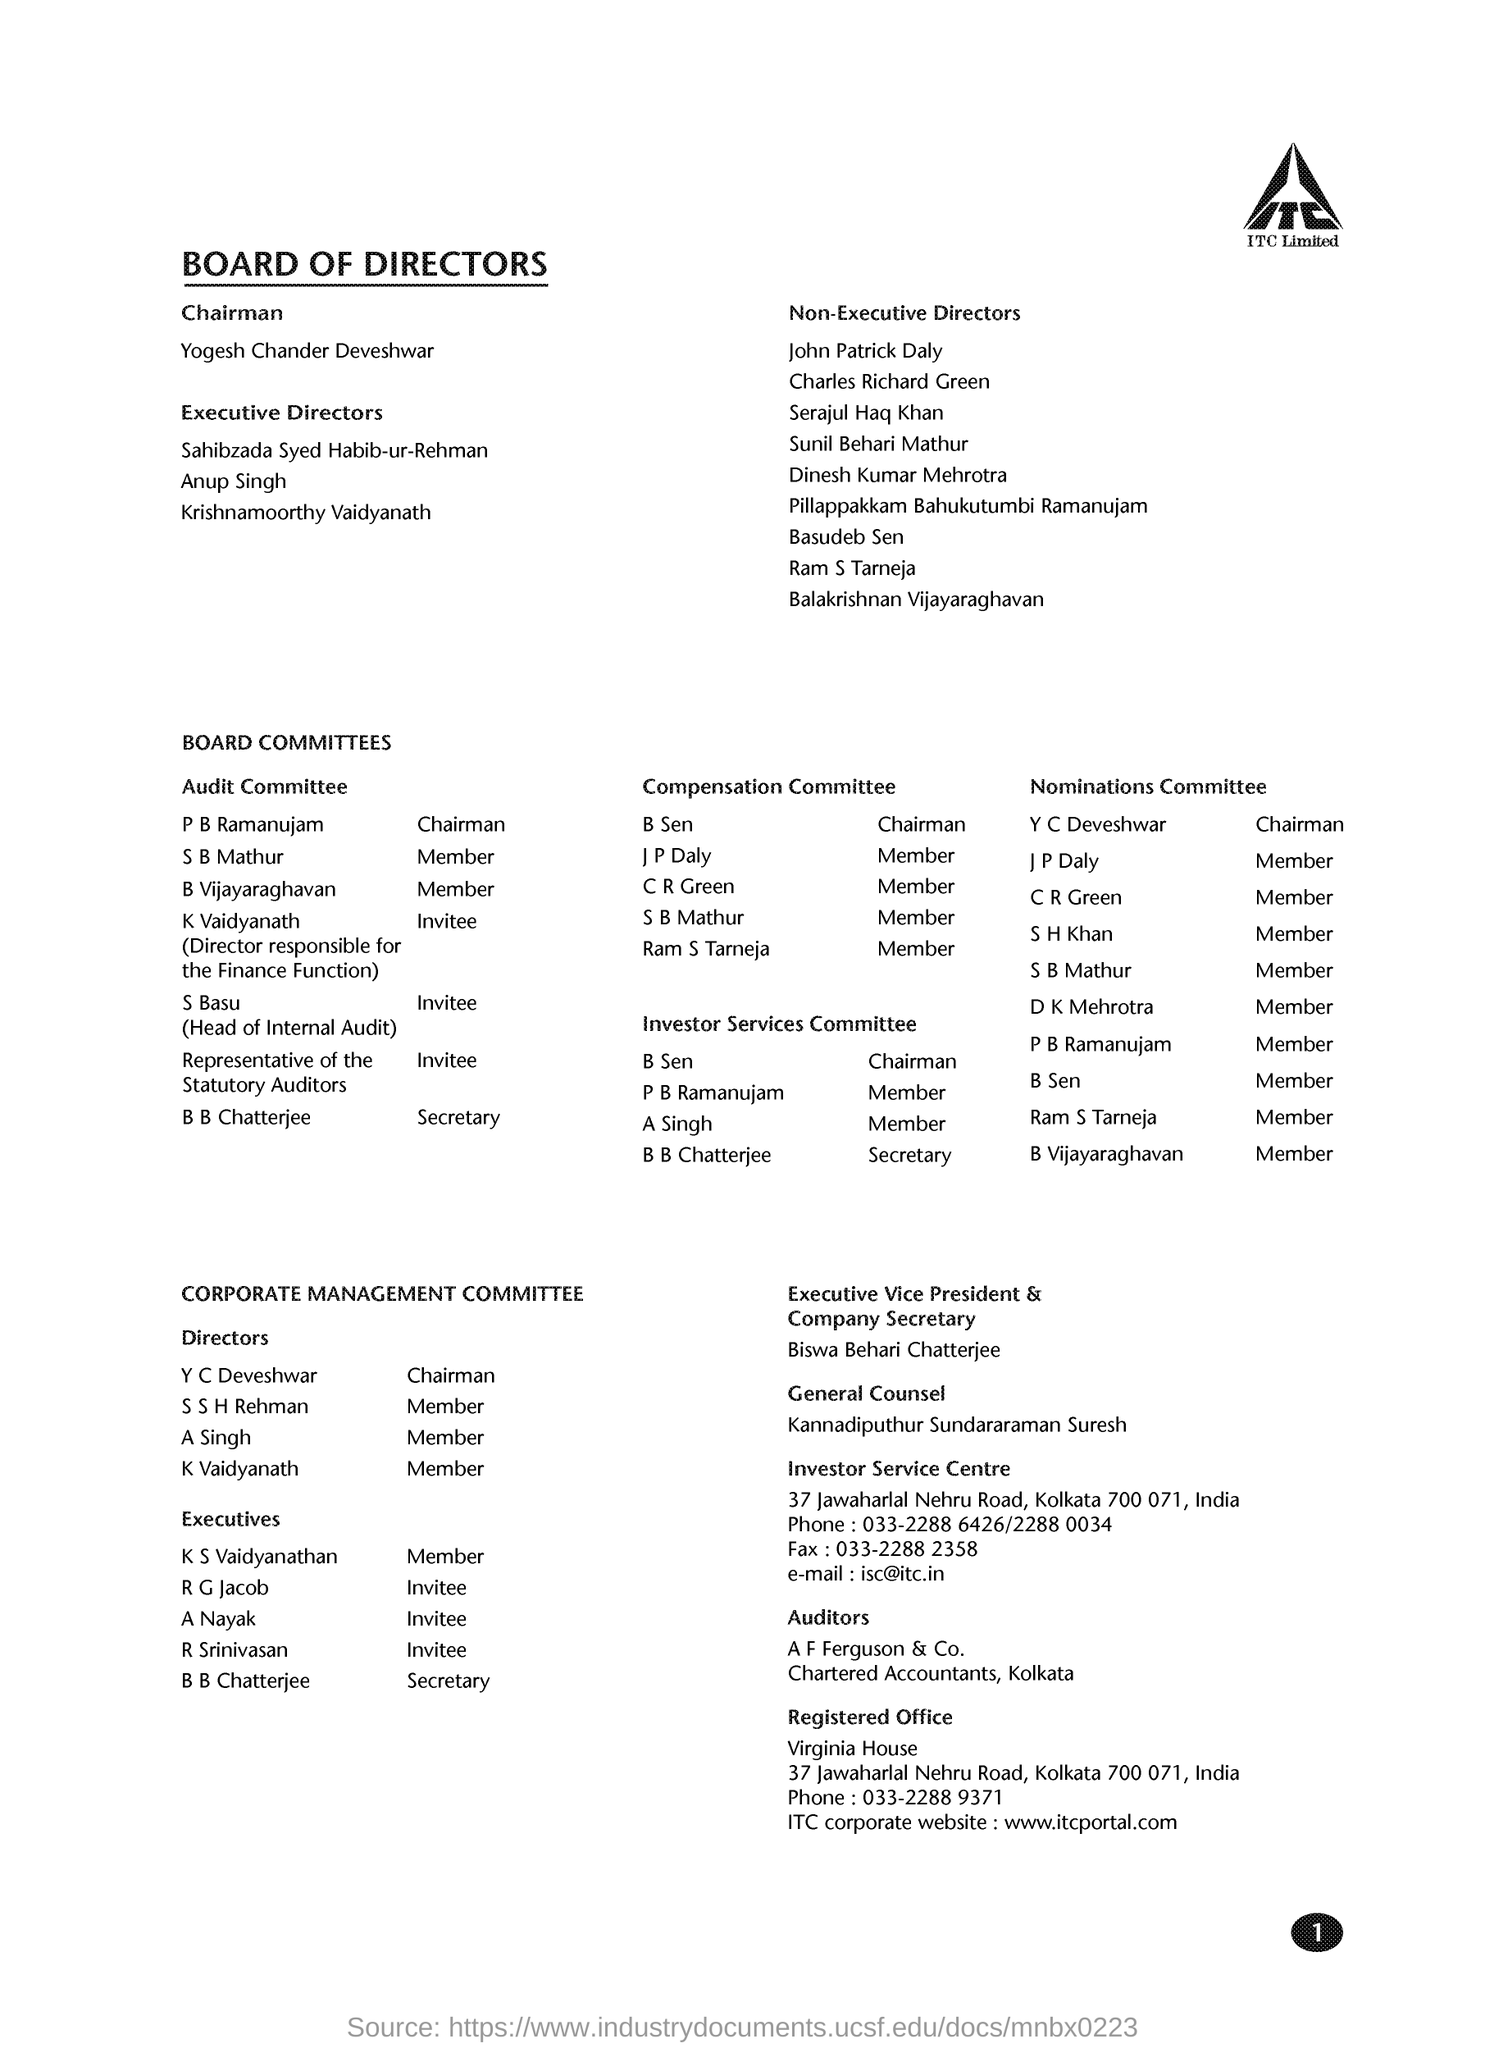Which company is mentioned in the document?
Keep it short and to the point. ITC Limited. In which city the registered office is located?
Offer a very short reply. Kolkata. Who is the executive vice president of the company?
Your response must be concise. Biswa Behari Chatterjee. 